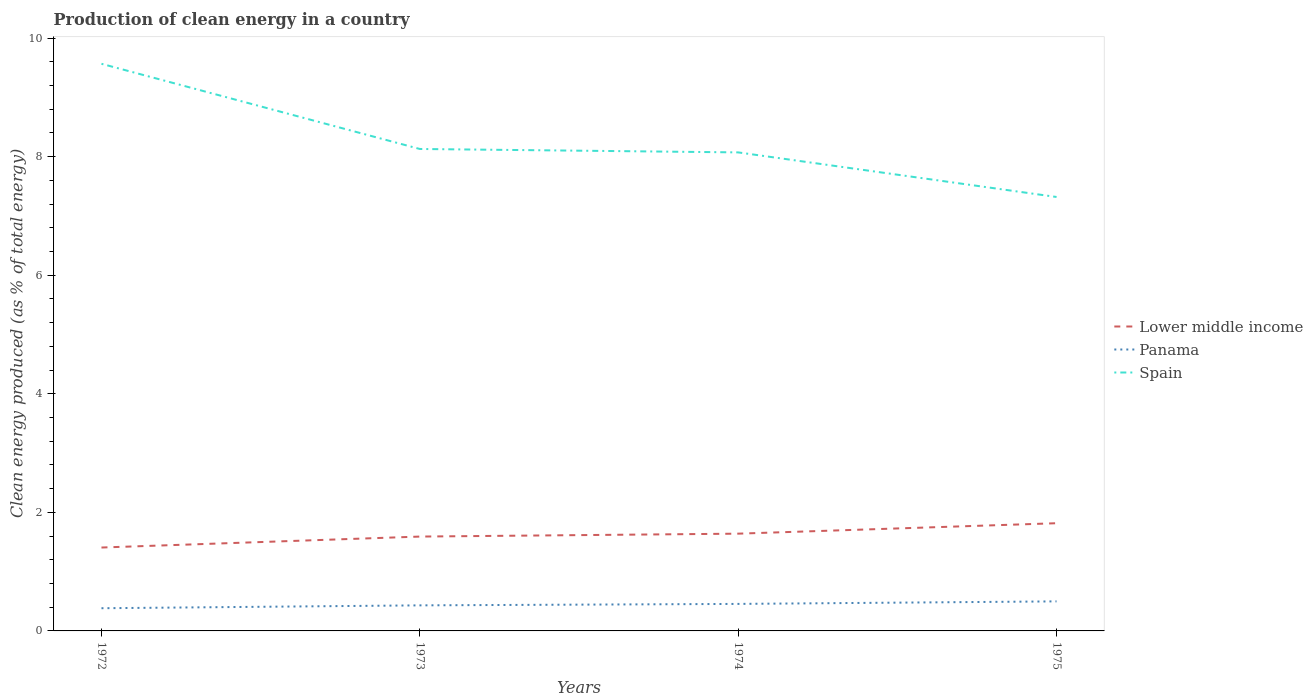Is the number of lines equal to the number of legend labels?
Give a very brief answer. Yes. Across all years, what is the maximum percentage of clean energy produced in Lower middle income?
Your response must be concise. 1.41. What is the total percentage of clean energy produced in Spain in the graph?
Give a very brief answer. 0.81. What is the difference between the highest and the second highest percentage of clean energy produced in Spain?
Provide a short and direct response. 2.25. What is the difference between the highest and the lowest percentage of clean energy produced in Lower middle income?
Offer a terse response. 2. Is the percentage of clean energy produced in Lower middle income strictly greater than the percentage of clean energy produced in Spain over the years?
Provide a succinct answer. Yes. How many lines are there?
Provide a short and direct response. 3. What is the difference between two consecutive major ticks on the Y-axis?
Provide a short and direct response. 2. Does the graph contain grids?
Offer a terse response. No. Where does the legend appear in the graph?
Offer a terse response. Center right. How are the legend labels stacked?
Provide a succinct answer. Vertical. What is the title of the graph?
Offer a terse response. Production of clean energy in a country. Does "Least developed countries" appear as one of the legend labels in the graph?
Offer a very short reply. No. What is the label or title of the Y-axis?
Offer a very short reply. Clean energy produced (as % of total energy). What is the Clean energy produced (as % of total energy) of Lower middle income in 1972?
Make the answer very short. 1.41. What is the Clean energy produced (as % of total energy) of Panama in 1972?
Ensure brevity in your answer.  0.38. What is the Clean energy produced (as % of total energy) in Spain in 1972?
Ensure brevity in your answer.  9.57. What is the Clean energy produced (as % of total energy) of Lower middle income in 1973?
Provide a succinct answer. 1.59. What is the Clean energy produced (as % of total energy) in Panama in 1973?
Offer a very short reply. 0.43. What is the Clean energy produced (as % of total energy) in Spain in 1973?
Your response must be concise. 8.13. What is the Clean energy produced (as % of total energy) of Lower middle income in 1974?
Your answer should be compact. 1.64. What is the Clean energy produced (as % of total energy) of Panama in 1974?
Provide a short and direct response. 0.46. What is the Clean energy produced (as % of total energy) in Spain in 1974?
Ensure brevity in your answer.  8.07. What is the Clean energy produced (as % of total energy) of Lower middle income in 1975?
Your answer should be compact. 1.82. What is the Clean energy produced (as % of total energy) of Panama in 1975?
Provide a short and direct response. 0.5. What is the Clean energy produced (as % of total energy) of Spain in 1975?
Ensure brevity in your answer.  7.32. Across all years, what is the maximum Clean energy produced (as % of total energy) in Lower middle income?
Offer a very short reply. 1.82. Across all years, what is the maximum Clean energy produced (as % of total energy) in Panama?
Your answer should be very brief. 0.5. Across all years, what is the maximum Clean energy produced (as % of total energy) of Spain?
Offer a very short reply. 9.57. Across all years, what is the minimum Clean energy produced (as % of total energy) in Lower middle income?
Your response must be concise. 1.41. Across all years, what is the minimum Clean energy produced (as % of total energy) of Panama?
Give a very brief answer. 0.38. Across all years, what is the minimum Clean energy produced (as % of total energy) in Spain?
Offer a very short reply. 7.32. What is the total Clean energy produced (as % of total energy) of Lower middle income in the graph?
Your response must be concise. 6.45. What is the total Clean energy produced (as % of total energy) in Panama in the graph?
Provide a succinct answer. 1.77. What is the total Clean energy produced (as % of total energy) in Spain in the graph?
Make the answer very short. 33.08. What is the difference between the Clean energy produced (as % of total energy) in Lower middle income in 1972 and that in 1973?
Provide a short and direct response. -0.18. What is the difference between the Clean energy produced (as % of total energy) of Panama in 1972 and that in 1973?
Your answer should be very brief. -0.05. What is the difference between the Clean energy produced (as % of total energy) of Spain in 1972 and that in 1973?
Your answer should be compact. 1.44. What is the difference between the Clean energy produced (as % of total energy) in Lower middle income in 1972 and that in 1974?
Keep it short and to the point. -0.23. What is the difference between the Clean energy produced (as % of total energy) in Panama in 1972 and that in 1974?
Keep it short and to the point. -0.07. What is the difference between the Clean energy produced (as % of total energy) in Spain in 1972 and that in 1974?
Offer a very short reply. 1.49. What is the difference between the Clean energy produced (as % of total energy) in Lower middle income in 1972 and that in 1975?
Offer a terse response. -0.41. What is the difference between the Clean energy produced (as % of total energy) in Panama in 1972 and that in 1975?
Make the answer very short. -0.12. What is the difference between the Clean energy produced (as % of total energy) of Spain in 1972 and that in 1975?
Offer a terse response. 2.25. What is the difference between the Clean energy produced (as % of total energy) in Lower middle income in 1973 and that in 1974?
Keep it short and to the point. -0.05. What is the difference between the Clean energy produced (as % of total energy) in Panama in 1973 and that in 1974?
Your answer should be compact. -0.02. What is the difference between the Clean energy produced (as % of total energy) in Spain in 1973 and that in 1974?
Your answer should be very brief. 0.06. What is the difference between the Clean energy produced (as % of total energy) in Lower middle income in 1973 and that in 1975?
Ensure brevity in your answer.  -0.23. What is the difference between the Clean energy produced (as % of total energy) of Panama in 1973 and that in 1975?
Your answer should be compact. -0.07. What is the difference between the Clean energy produced (as % of total energy) of Spain in 1973 and that in 1975?
Keep it short and to the point. 0.81. What is the difference between the Clean energy produced (as % of total energy) in Lower middle income in 1974 and that in 1975?
Give a very brief answer. -0.18. What is the difference between the Clean energy produced (as % of total energy) of Panama in 1974 and that in 1975?
Make the answer very short. -0.04. What is the difference between the Clean energy produced (as % of total energy) in Spain in 1974 and that in 1975?
Make the answer very short. 0.75. What is the difference between the Clean energy produced (as % of total energy) in Lower middle income in 1972 and the Clean energy produced (as % of total energy) in Panama in 1973?
Ensure brevity in your answer.  0.98. What is the difference between the Clean energy produced (as % of total energy) in Lower middle income in 1972 and the Clean energy produced (as % of total energy) in Spain in 1973?
Give a very brief answer. -6.72. What is the difference between the Clean energy produced (as % of total energy) of Panama in 1972 and the Clean energy produced (as % of total energy) of Spain in 1973?
Keep it short and to the point. -7.75. What is the difference between the Clean energy produced (as % of total energy) in Lower middle income in 1972 and the Clean energy produced (as % of total energy) in Panama in 1974?
Keep it short and to the point. 0.95. What is the difference between the Clean energy produced (as % of total energy) of Lower middle income in 1972 and the Clean energy produced (as % of total energy) of Spain in 1974?
Provide a succinct answer. -6.66. What is the difference between the Clean energy produced (as % of total energy) in Panama in 1972 and the Clean energy produced (as % of total energy) in Spain in 1974?
Provide a short and direct response. -7.69. What is the difference between the Clean energy produced (as % of total energy) in Lower middle income in 1972 and the Clean energy produced (as % of total energy) in Panama in 1975?
Provide a short and direct response. 0.91. What is the difference between the Clean energy produced (as % of total energy) of Lower middle income in 1972 and the Clean energy produced (as % of total energy) of Spain in 1975?
Give a very brief answer. -5.91. What is the difference between the Clean energy produced (as % of total energy) of Panama in 1972 and the Clean energy produced (as % of total energy) of Spain in 1975?
Provide a succinct answer. -6.94. What is the difference between the Clean energy produced (as % of total energy) of Lower middle income in 1973 and the Clean energy produced (as % of total energy) of Panama in 1974?
Keep it short and to the point. 1.14. What is the difference between the Clean energy produced (as % of total energy) in Lower middle income in 1973 and the Clean energy produced (as % of total energy) in Spain in 1974?
Ensure brevity in your answer.  -6.48. What is the difference between the Clean energy produced (as % of total energy) in Panama in 1973 and the Clean energy produced (as % of total energy) in Spain in 1974?
Your answer should be compact. -7.64. What is the difference between the Clean energy produced (as % of total energy) in Lower middle income in 1973 and the Clean energy produced (as % of total energy) in Panama in 1975?
Provide a short and direct response. 1.09. What is the difference between the Clean energy produced (as % of total energy) in Lower middle income in 1973 and the Clean energy produced (as % of total energy) in Spain in 1975?
Offer a very short reply. -5.73. What is the difference between the Clean energy produced (as % of total energy) of Panama in 1973 and the Clean energy produced (as % of total energy) of Spain in 1975?
Give a very brief answer. -6.89. What is the difference between the Clean energy produced (as % of total energy) in Lower middle income in 1974 and the Clean energy produced (as % of total energy) in Panama in 1975?
Ensure brevity in your answer.  1.14. What is the difference between the Clean energy produced (as % of total energy) in Lower middle income in 1974 and the Clean energy produced (as % of total energy) in Spain in 1975?
Ensure brevity in your answer.  -5.68. What is the difference between the Clean energy produced (as % of total energy) in Panama in 1974 and the Clean energy produced (as % of total energy) in Spain in 1975?
Your response must be concise. -6.86. What is the average Clean energy produced (as % of total energy) of Lower middle income per year?
Your response must be concise. 1.61. What is the average Clean energy produced (as % of total energy) of Panama per year?
Keep it short and to the point. 0.44. What is the average Clean energy produced (as % of total energy) in Spain per year?
Offer a terse response. 8.27. In the year 1972, what is the difference between the Clean energy produced (as % of total energy) in Lower middle income and Clean energy produced (as % of total energy) in Panama?
Give a very brief answer. 1.02. In the year 1972, what is the difference between the Clean energy produced (as % of total energy) in Lower middle income and Clean energy produced (as % of total energy) in Spain?
Offer a very short reply. -8.16. In the year 1972, what is the difference between the Clean energy produced (as % of total energy) in Panama and Clean energy produced (as % of total energy) in Spain?
Give a very brief answer. -9.18. In the year 1973, what is the difference between the Clean energy produced (as % of total energy) in Lower middle income and Clean energy produced (as % of total energy) in Panama?
Provide a succinct answer. 1.16. In the year 1973, what is the difference between the Clean energy produced (as % of total energy) of Lower middle income and Clean energy produced (as % of total energy) of Spain?
Ensure brevity in your answer.  -6.54. In the year 1973, what is the difference between the Clean energy produced (as % of total energy) in Panama and Clean energy produced (as % of total energy) in Spain?
Your answer should be compact. -7.7. In the year 1974, what is the difference between the Clean energy produced (as % of total energy) of Lower middle income and Clean energy produced (as % of total energy) of Panama?
Your response must be concise. 1.18. In the year 1974, what is the difference between the Clean energy produced (as % of total energy) in Lower middle income and Clean energy produced (as % of total energy) in Spain?
Offer a terse response. -6.43. In the year 1974, what is the difference between the Clean energy produced (as % of total energy) of Panama and Clean energy produced (as % of total energy) of Spain?
Give a very brief answer. -7.62. In the year 1975, what is the difference between the Clean energy produced (as % of total energy) of Lower middle income and Clean energy produced (as % of total energy) of Panama?
Make the answer very short. 1.32. In the year 1975, what is the difference between the Clean energy produced (as % of total energy) in Lower middle income and Clean energy produced (as % of total energy) in Spain?
Keep it short and to the point. -5.5. In the year 1975, what is the difference between the Clean energy produced (as % of total energy) in Panama and Clean energy produced (as % of total energy) in Spain?
Offer a terse response. -6.82. What is the ratio of the Clean energy produced (as % of total energy) in Lower middle income in 1972 to that in 1973?
Ensure brevity in your answer.  0.88. What is the ratio of the Clean energy produced (as % of total energy) in Panama in 1972 to that in 1973?
Your response must be concise. 0.89. What is the ratio of the Clean energy produced (as % of total energy) of Spain in 1972 to that in 1973?
Offer a terse response. 1.18. What is the ratio of the Clean energy produced (as % of total energy) of Lower middle income in 1972 to that in 1974?
Your answer should be very brief. 0.86. What is the ratio of the Clean energy produced (as % of total energy) of Panama in 1972 to that in 1974?
Give a very brief answer. 0.84. What is the ratio of the Clean energy produced (as % of total energy) of Spain in 1972 to that in 1974?
Ensure brevity in your answer.  1.19. What is the ratio of the Clean energy produced (as % of total energy) in Lower middle income in 1972 to that in 1975?
Your response must be concise. 0.77. What is the ratio of the Clean energy produced (as % of total energy) of Panama in 1972 to that in 1975?
Your answer should be very brief. 0.77. What is the ratio of the Clean energy produced (as % of total energy) in Spain in 1972 to that in 1975?
Ensure brevity in your answer.  1.31. What is the ratio of the Clean energy produced (as % of total energy) in Lower middle income in 1973 to that in 1974?
Ensure brevity in your answer.  0.97. What is the ratio of the Clean energy produced (as % of total energy) of Panama in 1973 to that in 1974?
Ensure brevity in your answer.  0.95. What is the ratio of the Clean energy produced (as % of total energy) of Spain in 1973 to that in 1974?
Offer a very short reply. 1.01. What is the ratio of the Clean energy produced (as % of total energy) of Lower middle income in 1973 to that in 1975?
Ensure brevity in your answer.  0.88. What is the ratio of the Clean energy produced (as % of total energy) in Panama in 1973 to that in 1975?
Provide a short and direct response. 0.87. What is the ratio of the Clean energy produced (as % of total energy) in Spain in 1973 to that in 1975?
Offer a terse response. 1.11. What is the ratio of the Clean energy produced (as % of total energy) of Lower middle income in 1974 to that in 1975?
Give a very brief answer. 0.9. What is the ratio of the Clean energy produced (as % of total energy) of Panama in 1974 to that in 1975?
Provide a succinct answer. 0.91. What is the ratio of the Clean energy produced (as % of total energy) in Spain in 1974 to that in 1975?
Offer a terse response. 1.1. What is the difference between the highest and the second highest Clean energy produced (as % of total energy) in Lower middle income?
Your answer should be very brief. 0.18. What is the difference between the highest and the second highest Clean energy produced (as % of total energy) of Panama?
Offer a very short reply. 0.04. What is the difference between the highest and the second highest Clean energy produced (as % of total energy) of Spain?
Give a very brief answer. 1.44. What is the difference between the highest and the lowest Clean energy produced (as % of total energy) of Lower middle income?
Your answer should be very brief. 0.41. What is the difference between the highest and the lowest Clean energy produced (as % of total energy) in Panama?
Provide a succinct answer. 0.12. What is the difference between the highest and the lowest Clean energy produced (as % of total energy) in Spain?
Offer a very short reply. 2.25. 